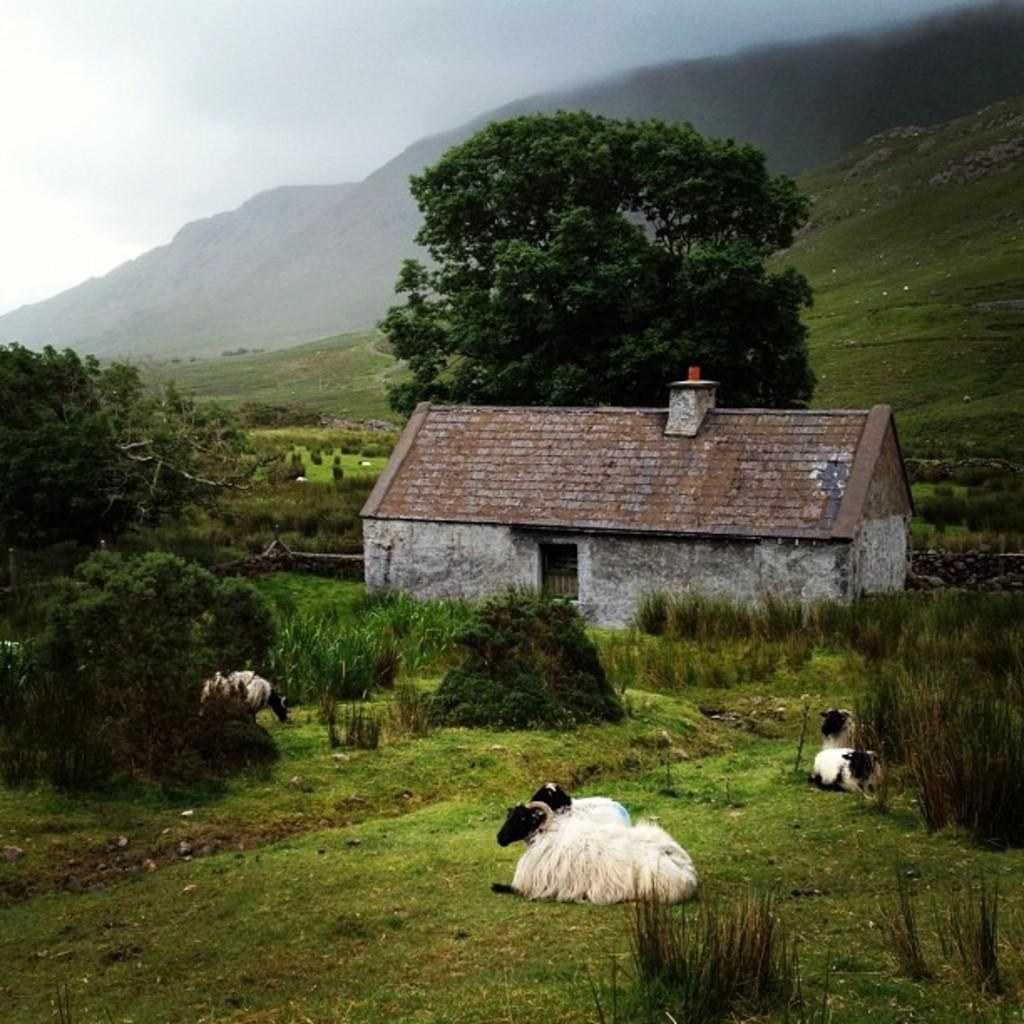Describe this image in one or two sentences. In this image there are a few cattle sat on the surface of the grass, in the background of the image there are trees, a house and mountains. 